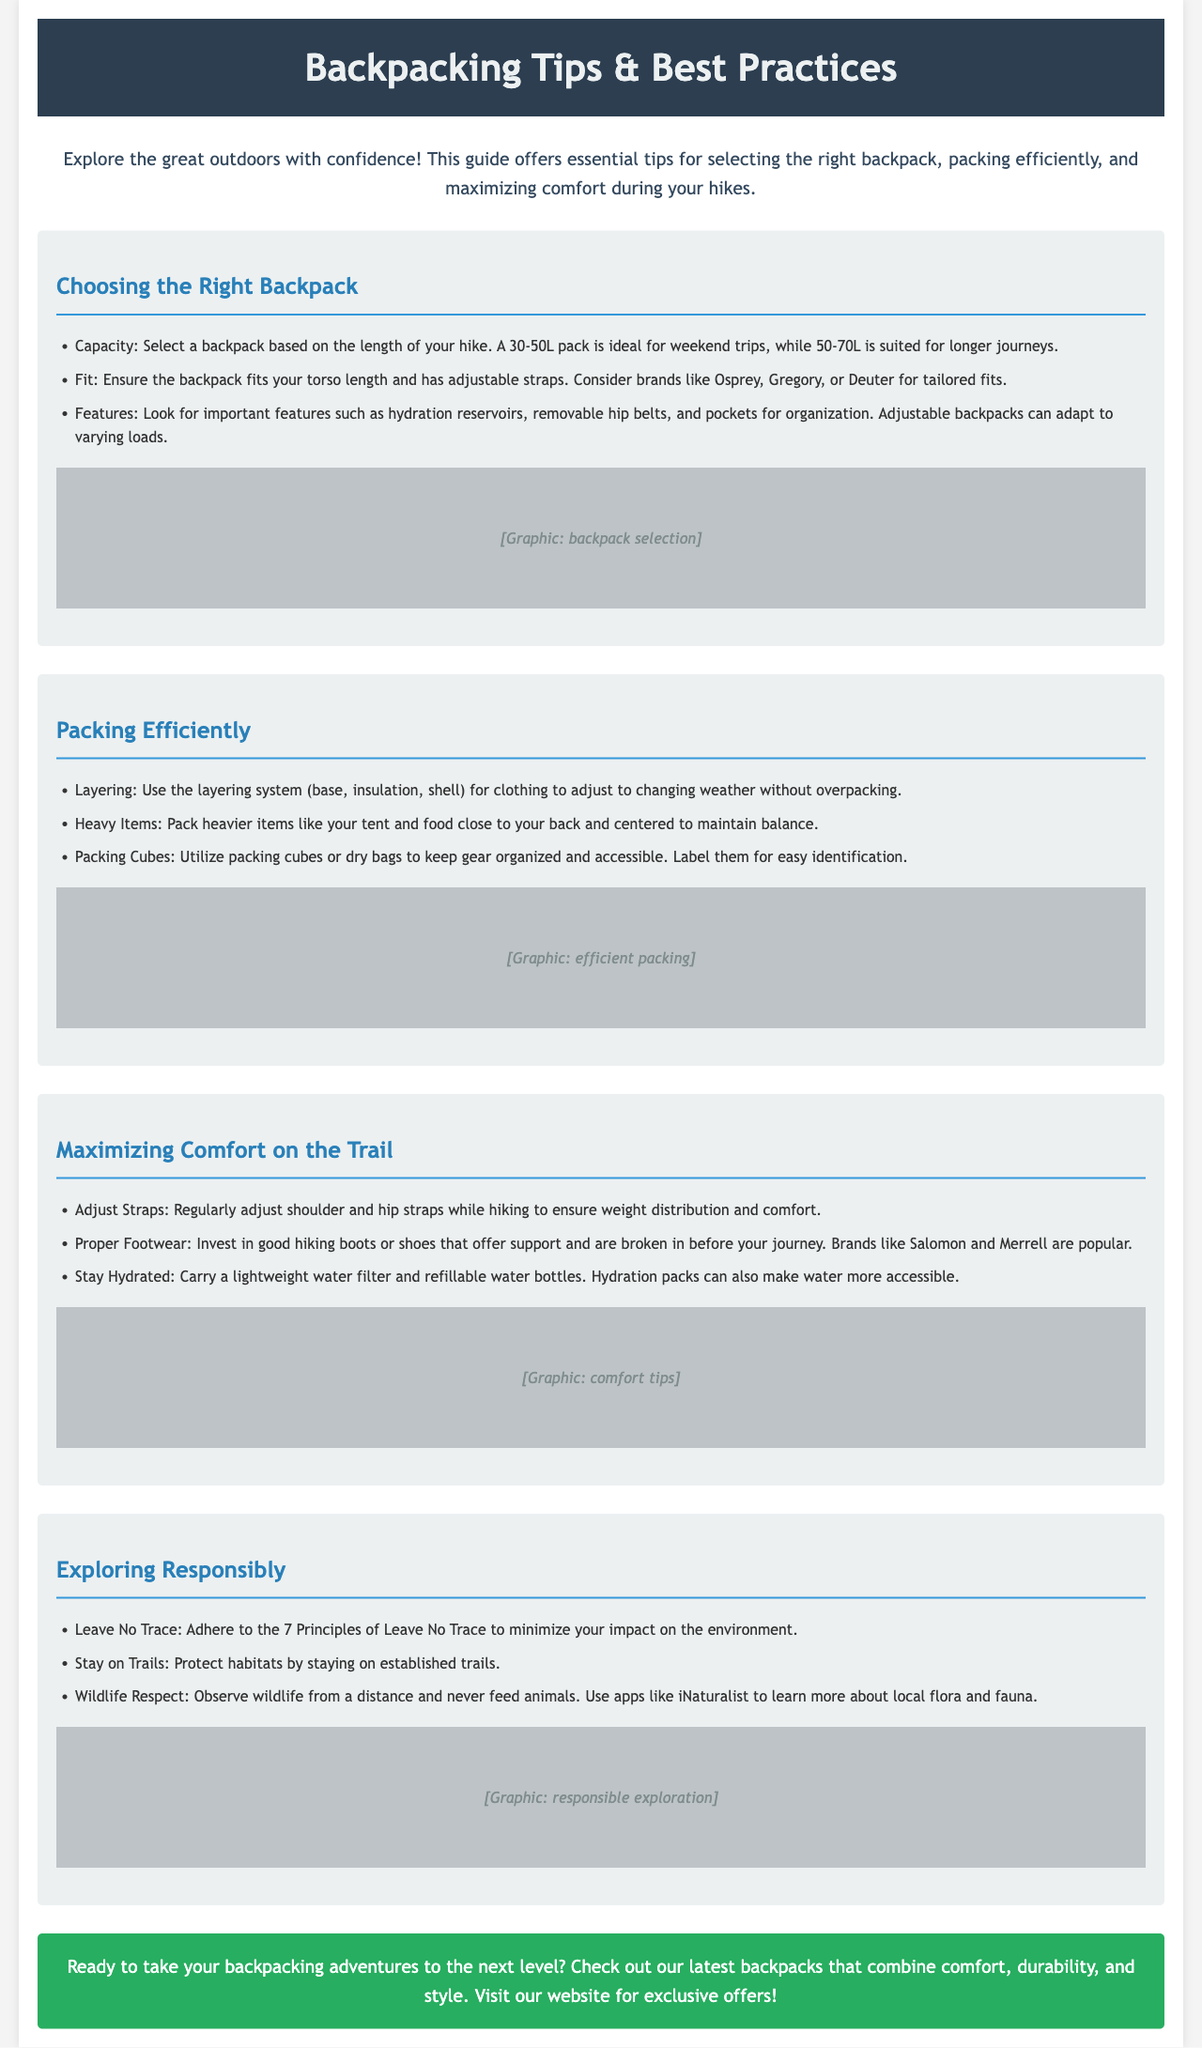What is the recommended pack size for weekend trips? The document specifies a 30-50L pack as ideal for weekend trips.
Answer: 30-50L Which brands are suggested for a good backpack fit? The document mentions Osprey, Gregory, and Deuter as brands for tailored fits.
Answer: Osprey, Gregory, Deuter What packing method is recommended for clothing? Layering is advised as the packing method for clothing adjustments.
Answer: Layering Where should heavier items be packed in the backpack? Heavier items should be packed close to your back and centered to maintain balance.
Answer: Close to your back and centered What are the 7 Principles that hikers should adhere to? These principles are not specified in detail but are referred to as "Leave No Trace."
Answer: Leave No Trace What is a benefit of using packing cubes? Packing cubes help keep gear organized and accessible, allowing for easy identification.
Answer: Organized and accessible How should strap adjustments be managed during hiking? The document advises to regularly adjust shoulder and hip straps for comfort.
Answer: Regularly adjust What footwear brands are recommended in the guide? Brands suggested for good hiking footwear include Salomon and Merrell.
Answer: Salomon, Merrell What type of water accessory is mentioned for hydration? The document mentions carrying a lightweight water filter as a hydration accessory.
Answer: Lightweight water filter 